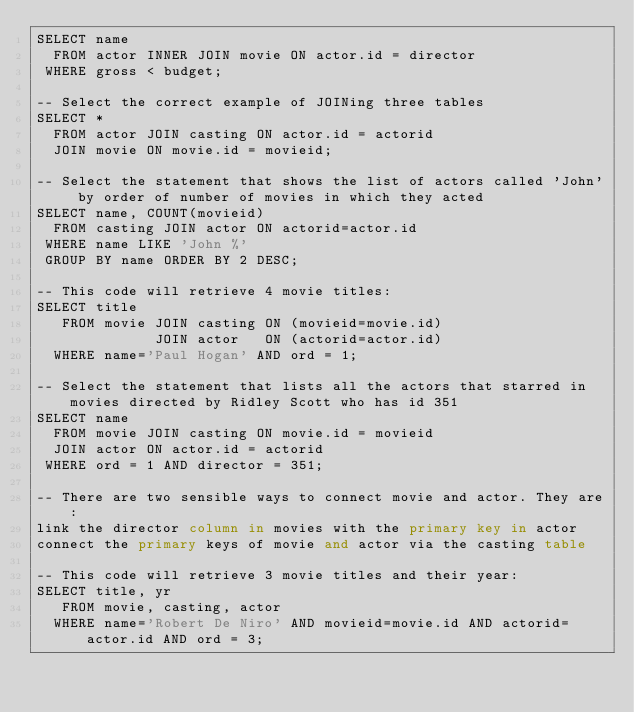<code> <loc_0><loc_0><loc_500><loc_500><_SQL_>SELECT name
  FROM actor INNER JOIN movie ON actor.id = director
 WHERE gross < budget;

-- Select the correct example of JOINing three tables
SELECT *
  FROM actor JOIN casting ON actor.id = actorid
  JOIN movie ON movie.id = movieid;

-- Select the statement that shows the list of actors called 'John' by order of number of movies in which they acted
SELECT name, COUNT(movieid)
  FROM casting JOIN actor ON actorid=actor.id
 WHERE name LIKE 'John %'
 GROUP BY name ORDER BY 2 DESC;

-- This code will retrieve 4 movie titles:
SELECT title 
   FROM movie JOIN casting ON (movieid=movie.id)
              JOIN actor   ON (actorid=actor.id)
  WHERE name='Paul Hogan' AND ord = 1;

-- Select the statement that lists all the actors that starred in movies directed by Ridley Scott who has id 351
SELECT name
  FROM movie JOIN casting ON movie.id = movieid
  JOIN actor ON actor.id = actorid
 WHERE ord = 1 AND director = 351;

-- There are two sensible ways to connect movie and actor. They are:
link the director column in movies with the primary key in actor
connect the primary keys of movie and actor via the casting table

-- This code will retrieve 3 movie titles and their year:
SELECT title, yr 
   FROM movie, casting, actor 
  WHERE name='Robert De Niro' AND movieid=movie.id AND actorid=actor.id AND ord = 3;
</code> 